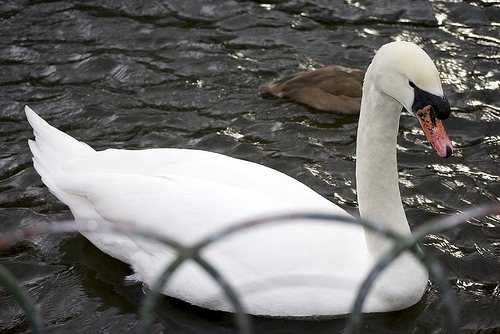<image>
Is there a bird above the swan? No. The bird is not positioned above the swan. The vertical arrangement shows a different relationship. 